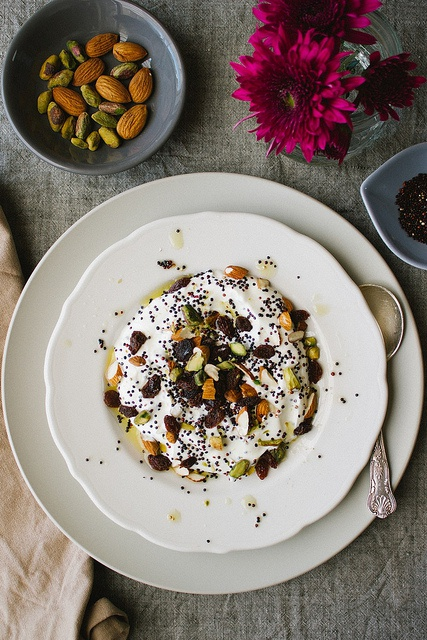Describe the objects in this image and their specific colors. I can see dining table in lightgray, black, darkgray, gray, and maroon tones, bowl in gray, black, olive, and maroon tones, bowl in gray, black, and darkblue tones, spoon in gray and darkgray tones, and vase in gray and black tones in this image. 